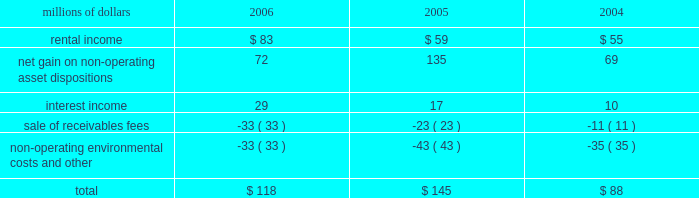The environmental liability includes costs for remediation and restoration of sites , as well as for ongoing monitoring costs , but excludes any anticipated recoveries from third parties .
Cost estimates are based on information available for each site , financial viability of other potentially responsible parties , and existing technology , laws , and regulations .
We believe that we have adequately accrued for our ultimate share of costs at sites subject to joint and several liability .
However , the ultimate liability for remediation is difficult to determine because of the number of potentially responsible parties involved , site-specific cost sharing arrangements with other potentially responsible parties , the degree of contamination by various wastes , the scarcity and quality of volumetric data related to many of the sites , and the speculative nature of remediation costs .
Estimates may also vary due to changes in federal , state , and local laws governing environmental remediation .
We do not expect current obligations to have a material adverse effect on our results of operations or financial condition .
Guarantees 2013 at december 31 , 2006 , we were contingently liable for $ 464 million in guarantees .
We have recorded a liability of $ 6 million for the fair value of these obligations as of december 31 , 2006 .
We entered into these contingent guarantees in the normal course of business , and they include guaranteed obligations related to our headquarters building , equipment financings , and affiliated operations .
The final guarantee expires in 2022 .
We are not aware of any existing event of default that would require us to satisfy these guarantees .
We do not expect that these guarantees will have a material adverse effect on our consolidated financial condition , results of operations , or liquidity .
Indemnities 2013 our maximum potential exposure under indemnification arrangements , including certain tax indemnifications , can range from a specified dollar amount to an unlimited amount , depending on the nature of the transactions and the agreements .
Due to uncertainty as to whether claims will be made or how they will be resolved , we cannot reasonably determine the probability of an adverse claim or reasonably estimate any adverse liability or the total maximum exposure under these indemnification arrangements .
We do not have any reason to believe that we will be required to make any material payments under these indemnity provisions .
Income taxes 2013 as previously reported in our form 10-q for the quarter ended september 30 , 2005 , the irs has completed its examinations and issued notices of deficiency for tax years 1995 through 2002 .
Among their proposed adjustments is the disallowance of tax deductions claimed in connection with certain donations of property .
In the fourth quarter of 2005 , the irs national office issued a technical advice memorandum which left unresolved whether the deductions were proper , pending further factual development .
We continue to dispute the donation issue , as well as many of the other proposed adjustments , and will contest the associated tax deficiencies through the irs appeals process , and , if necessary , litigation .
In addition , the irs is examining the corporation 2019s federal income tax returns for tax years 2003 and 2004 and should complete their exam in 2007 .
We do not expect that the ultimate resolution of these examinations will have a material adverse effect on our consolidated financial statements .
11 .
Other income other income included the following for the years ended december 31 : millions of dollars 2006 2005 2004 .

What was the percentage change in the rental income from 2005 to 2006? 
Computations: ((83 - 59) / 59)
Answer: 0.40678. 